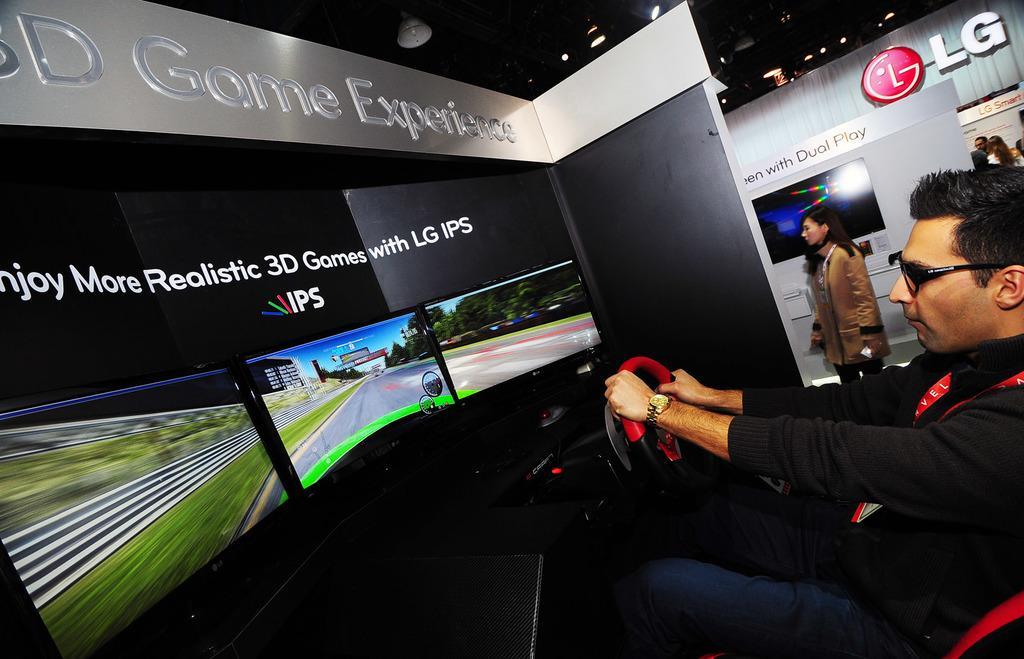In one or two sentences, can you explain what this image depicts? On the right side of this image I can see a man wearing black color jacket, jeans sitting in a chair and playing the video game. He is holding steering in the hands and looking into the screens which are in front of him. On the top I can see black color wall and a white color board. In the background there is a woman standing. At the back of her I can see a screen which is attached to a wall. On the top there are some lights. 